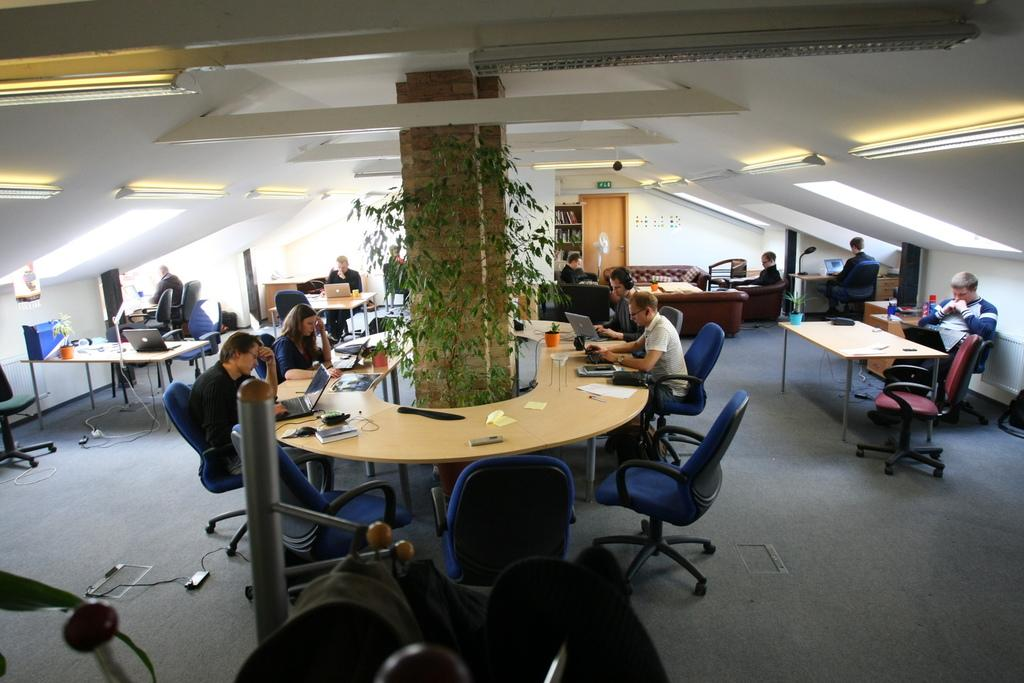What is happening in the image involving the people and the table? There are many people sitting in chairs around a table, suggesting they might be having a meeting or gathering. What can be seen in the middle of the room? There is a pillar in the middle of the room. What is growing on the pillar? The pillar has climbers around it. What type of furniture is present in the room besides the chairs? There is a sofa and a bookshelf in the room. What type of coal is being offered to the people sitting around the table? There is no coal present in the image; it features people sitting around a table with a pillar, climbers, a sofa, and a bookshelf. How many answers can be found on the bookshelf in the image? There are no answers present on the bookshelf in the image; it is a piece of furniture for storing books and other items. 